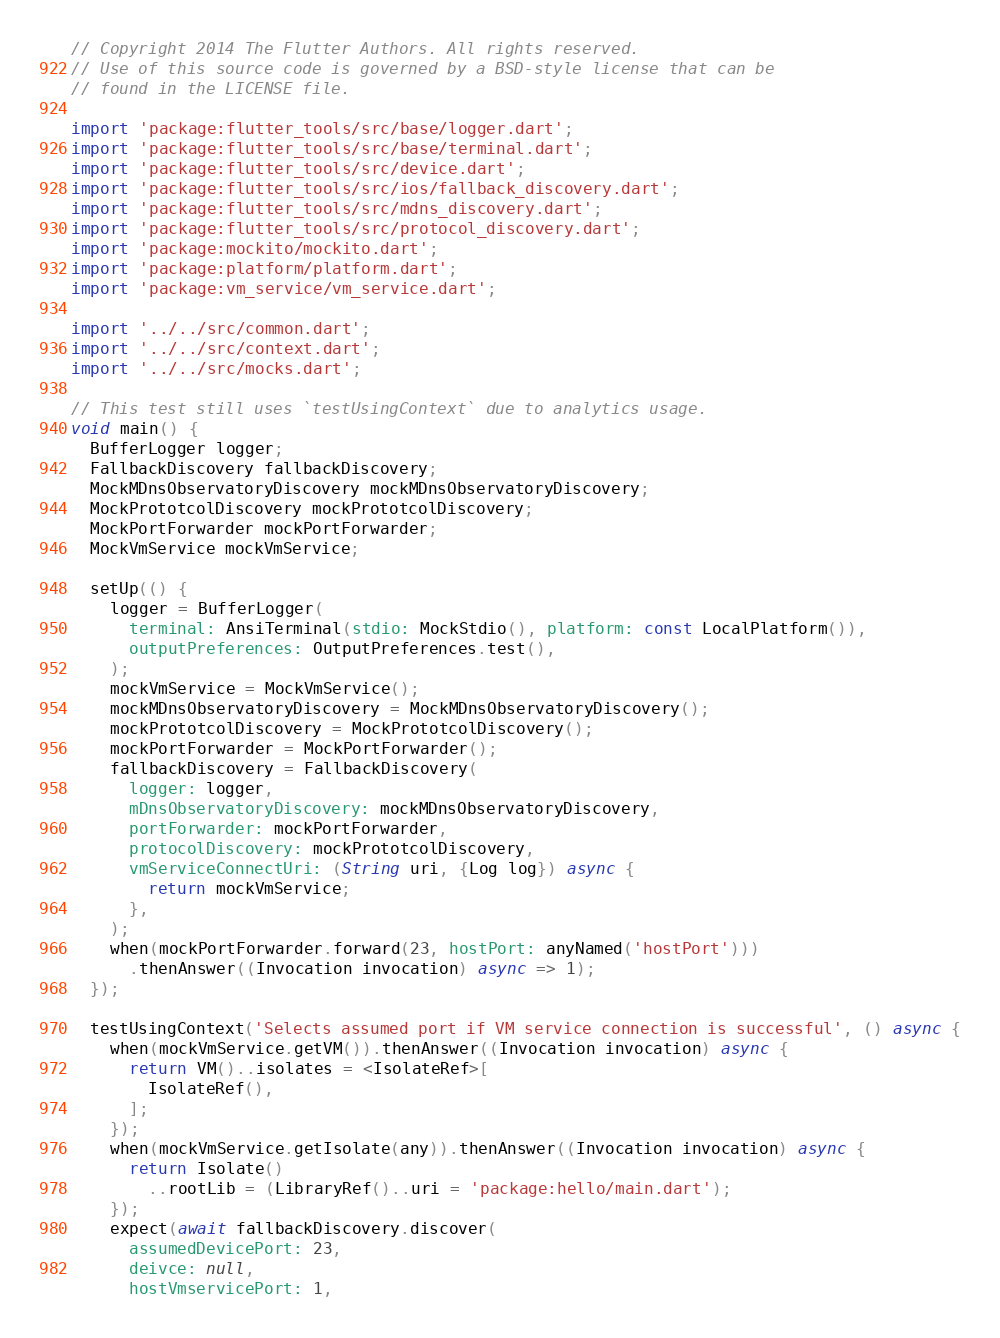Convert code to text. <code><loc_0><loc_0><loc_500><loc_500><_Dart_>// Copyright 2014 The Flutter Authors. All rights reserved.
// Use of this source code is governed by a BSD-style license that can be
// found in the LICENSE file.

import 'package:flutter_tools/src/base/logger.dart';
import 'package:flutter_tools/src/base/terminal.dart';
import 'package:flutter_tools/src/device.dart';
import 'package:flutter_tools/src/ios/fallback_discovery.dart';
import 'package:flutter_tools/src/mdns_discovery.dart';
import 'package:flutter_tools/src/protocol_discovery.dart';
import 'package:mockito/mockito.dart';
import 'package:platform/platform.dart';
import 'package:vm_service/vm_service.dart';

import '../../src/common.dart';
import '../../src/context.dart';
import '../../src/mocks.dart';

// This test still uses `testUsingContext` due to analytics usage.
void main() {
  BufferLogger logger;
  FallbackDiscovery fallbackDiscovery;
  MockMDnsObservatoryDiscovery mockMDnsObservatoryDiscovery;
  MockPrototcolDiscovery mockPrototcolDiscovery;
  MockPortForwarder mockPortForwarder;
  MockVmService mockVmService;

  setUp(() {
    logger = BufferLogger(
      terminal: AnsiTerminal(stdio: MockStdio(), platform: const LocalPlatform()),
      outputPreferences: OutputPreferences.test(),
    );
    mockVmService = MockVmService();
    mockMDnsObservatoryDiscovery = MockMDnsObservatoryDiscovery();
    mockPrototcolDiscovery = MockPrototcolDiscovery();
    mockPortForwarder = MockPortForwarder();
    fallbackDiscovery = FallbackDiscovery(
      logger: logger,
      mDnsObservatoryDiscovery: mockMDnsObservatoryDiscovery,
      portForwarder: mockPortForwarder,
      protocolDiscovery: mockPrototcolDiscovery,
      vmServiceConnectUri: (String uri, {Log log}) async {
        return mockVmService;
      },
    );
    when(mockPortForwarder.forward(23, hostPort: anyNamed('hostPort')))
      .thenAnswer((Invocation invocation) async => 1);
  });

  testUsingContext('Selects assumed port if VM service connection is successful', () async {
    when(mockVmService.getVM()).thenAnswer((Invocation invocation) async {
      return VM()..isolates = <IsolateRef>[
        IsolateRef(),
      ];
    });
    when(mockVmService.getIsolate(any)).thenAnswer((Invocation invocation) async {
      return Isolate()
        ..rootLib = (LibraryRef()..uri = 'package:hello/main.dart');
    });
    expect(await fallbackDiscovery.discover(
      assumedDevicePort: 23,
      deivce: null,
      hostVmservicePort: 1,</code> 